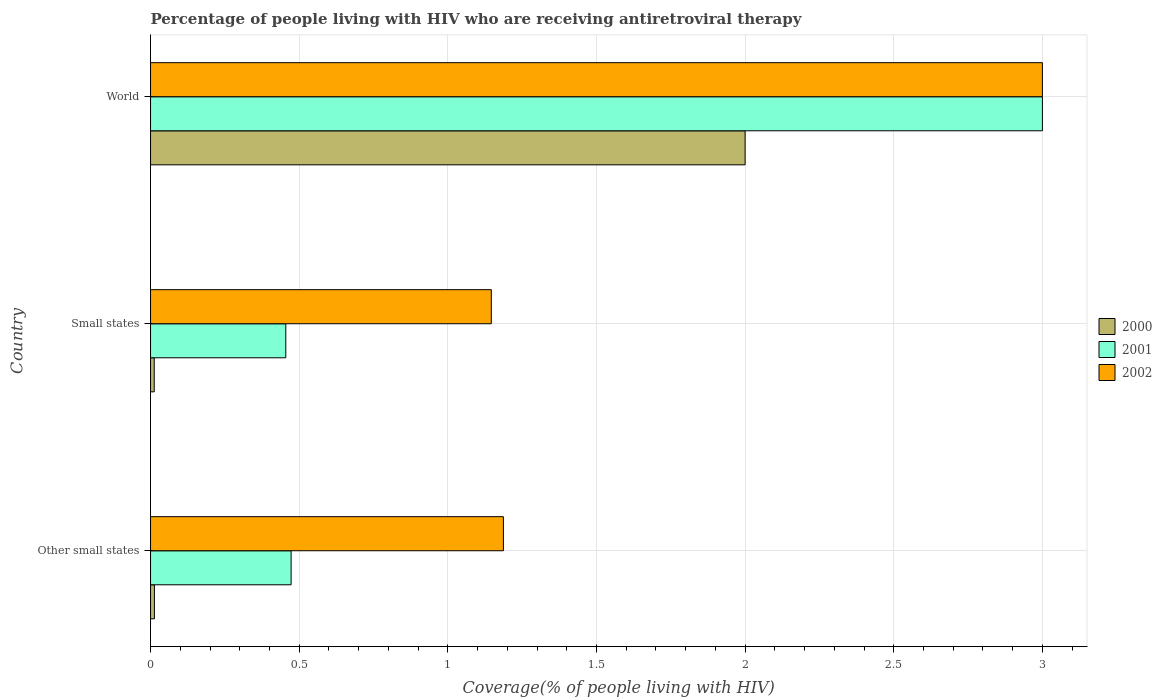Are the number of bars per tick equal to the number of legend labels?
Offer a terse response. Yes. Are the number of bars on each tick of the Y-axis equal?
Make the answer very short. Yes. How many bars are there on the 3rd tick from the bottom?
Keep it short and to the point. 3. What is the label of the 2nd group of bars from the top?
Keep it short and to the point. Small states. What is the percentage of the HIV infected people who are receiving antiretroviral therapy in 2002 in Small states?
Provide a short and direct response. 1.15. Across all countries, what is the minimum percentage of the HIV infected people who are receiving antiretroviral therapy in 2000?
Keep it short and to the point. 0.01. In which country was the percentage of the HIV infected people who are receiving antiretroviral therapy in 2001 maximum?
Your answer should be compact. World. In which country was the percentage of the HIV infected people who are receiving antiretroviral therapy in 2002 minimum?
Make the answer very short. Small states. What is the total percentage of the HIV infected people who are receiving antiretroviral therapy in 2002 in the graph?
Your answer should be very brief. 5.33. What is the difference between the percentage of the HIV infected people who are receiving antiretroviral therapy in 2000 in Other small states and that in World?
Provide a succinct answer. -1.99. What is the difference between the percentage of the HIV infected people who are receiving antiretroviral therapy in 2000 in Small states and the percentage of the HIV infected people who are receiving antiretroviral therapy in 2002 in World?
Ensure brevity in your answer.  -2.99. What is the average percentage of the HIV infected people who are receiving antiretroviral therapy in 2002 per country?
Offer a terse response. 1.78. What is the difference between the percentage of the HIV infected people who are receiving antiretroviral therapy in 2002 and percentage of the HIV infected people who are receiving antiretroviral therapy in 2001 in World?
Offer a terse response. 0. In how many countries, is the percentage of the HIV infected people who are receiving antiretroviral therapy in 2002 greater than 1.2 %?
Offer a terse response. 1. What is the ratio of the percentage of the HIV infected people who are receiving antiretroviral therapy in 2000 in Other small states to that in World?
Ensure brevity in your answer.  0.01. Is the percentage of the HIV infected people who are receiving antiretroviral therapy in 2001 in Other small states less than that in Small states?
Your response must be concise. No. What is the difference between the highest and the second highest percentage of the HIV infected people who are receiving antiretroviral therapy in 2000?
Your response must be concise. 1.99. What is the difference between the highest and the lowest percentage of the HIV infected people who are receiving antiretroviral therapy in 2000?
Make the answer very short. 1.99. Is the sum of the percentage of the HIV infected people who are receiving antiretroviral therapy in 2001 in Other small states and Small states greater than the maximum percentage of the HIV infected people who are receiving antiretroviral therapy in 2000 across all countries?
Keep it short and to the point. No. What does the 1st bar from the top in Other small states represents?
Provide a short and direct response. 2002. What does the 3rd bar from the bottom in Other small states represents?
Provide a succinct answer. 2002. Is it the case that in every country, the sum of the percentage of the HIV infected people who are receiving antiretroviral therapy in 2002 and percentage of the HIV infected people who are receiving antiretroviral therapy in 2000 is greater than the percentage of the HIV infected people who are receiving antiretroviral therapy in 2001?
Provide a short and direct response. Yes. How many countries are there in the graph?
Your answer should be compact. 3. Does the graph contain any zero values?
Keep it short and to the point. No. Where does the legend appear in the graph?
Provide a short and direct response. Center right. What is the title of the graph?
Ensure brevity in your answer.  Percentage of people living with HIV who are receiving antiretroviral therapy. Does "2000" appear as one of the legend labels in the graph?
Your answer should be very brief. Yes. What is the label or title of the X-axis?
Keep it short and to the point. Coverage(% of people living with HIV). What is the Coverage(% of people living with HIV) of 2000 in Other small states?
Make the answer very short. 0.01. What is the Coverage(% of people living with HIV) in 2001 in Other small states?
Provide a succinct answer. 0.47. What is the Coverage(% of people living with HIV) in 2002 in Other small states?
Keep it short and to the point. 1.19. What is the Coverage(% of people living with HIV) in 2000 in Small states?
Your response must be concise. 0.01. What is the Coverage(% of people living with HIV) of 2001 in Small states?
Ensure brevity in your answer.  0.45. What is the Coverage(% of people living with HIV) of 2002 in Small states?
Your response must be concise. 1.15. What is the Coverage(% of people living with HIV) of 2000 in World?
Keep it short and to the point. 2. What is the Coverage(% of people living with HIV) in 2001 in World?
Provide a succinct answer. 3. Across all countries, what is the maximum Coverage(% of people living with HIV) of 2001?
Provide a succinct answer. 3. Across all countries, what is the maximum Coverage(% of people living with HIV) of 2002?
Provide a short and direct response. 3. Across all countries, what is the minimum Coverage(% of people living with HIV) in 2000?
Keep it short and to the point. 0.01. Across all countries, what is the minimum Coverage(% of people living with HIV) of 2001?
Make the answer very short. 0.45. Across all countries, what is the minimum Coverage(% of people living with HIV) of 2002?
Your answer should be compact. 1.15. What is the total Coverage(% of people living with HIV) of 2000 in the graph?
Give a very brief answer. 2.03. What is the total Coverage(% of people living with HIV) in 2001 in the graph?
Offer a terse response. 3.93. What is the total Coverage(% of people living with HIV) in 2002 in the graph?
Offer a very short reply. 5.33. What is the difference between the Coverage(% of people living with HIV) of 2000 in Other small states and that in Small states?
Ensure brevity in your answer.  0. What is the difference between the Coverage(% of people living with HIV) in 2001 in Other small states and that in Small states?
Your response must be concise. 0.02. What is the difference between the Coverage(% of people living with HIV) of 2002 in Other small states and that in Small states?
Give a very brief answer. 0.04. What is the difference between the Coverage(% of people living with HIV) in 2000 in Other small states and that in World?
Your answer should be very brief. -1.99. What is the difference between the Coverage(% of people living with HIV) of 2001 in Other small states and that in World?
Provide a short and direct response. -2.53. What is the difference between the Coverage(% of people living with HIV) in 2002 in Other small states and that in World?
Provide a succinct answer. -1.81. What is the difference between the Coverage(% of people living with HIV) in 2000 in Small states and that in World?
Keep it short and to the point. -1.99. What is the difference between the Coverage(% of people living with HIV) in 2001 in Small states and that in World?
Ensure brevity in your answer.  -2.54. What is the difference between the Coverage(% of people living with HIV) of 2002 in Small states and that in World?
Provide a short and direct response. -1.85. What is the difference between the Coverage(% of people living with HIV) in 2000 in Other small states and the Coverage(% of people living with HIV) in 2001 in Small states?
Your response must be concise. -0.44. What is the difference between the Coverage(% of people living with HIV) of 2000 in Other small states and the Coverage(% of people living with HIV) of 2002 in Small states?
Your answer should be compact. -1.13. What is the difference between the Coverage(% of people living with HIV) of 2001 in Other small states and the Coverage(% of people living with HIV) of 2002 in Small states?
Offer a very short reply. -0.67. What is the difference between the Coverage(% of people living with HIV) of 2000 in Other small states and the Coverage(% of people living with HIV) of 2001 in World?
Ensure brevity in your answer.  -2.99. What is the difference between the Coverage(% of people living with HIV) in 2000 in Other small states and the Coverage(% of people living with HIV) in 2002 in World?
Your answer should be very brief. -2.99. What is the difference between the Coverage(% of people living with HIV) of 2001 in Other small states and the Coverage(% of people living with HIV) of 2002 in World?
Offer a terse response. -2.53. What is the difference between the Coverage(% of people living with HIV) in 2000 in Small states and the Coverage(% of people living with HIV) in 2001 in World?
Make the answer very short. -2.99. What is the difference between the Coverage(% of people living with HIV) in 2000 in Small states and the Coverage(% of people living with HIV) in 2002 in World?
Your answer should be compact. -2.99. What is the difference between the Coverage(% of people living with HIV) of 2001 in Small states and the Coverage(% of people living with HIV) of 2002 in World?
Your answer should be very brief. -2.54. What is the average Coverage(% of people living with HIV) in 2000 per country?
Your response must be concise. 0.68. What is the average Coverage(% of people living with HIV) of 2001 per country?
Make the answer very short. 1.31. What is the average Coverage(% of people living with HIV) of 2002 per country?
Your response must be concise. 1.78. What is the difference between the Coverage(% of people living with HIV) in 2000 and Coverage(% of people living with HIV) in 2001 in Other small states?
Ensure brevity in your answer.  -0.46. What is the difference between the Coverage(% of people living with HIV) in 2000 and Coverage(% of people living with HIV) in 2002 in Other small states?
Your answer should be compact. -1.17. What is the difference between the Coverage(% of people living with HIV) of 2001 and Coverage(% of people living with HIV) of 2002 in Other small states?
Offer a terse response. -0.71. What is the difference between the Coverage(% of people living with HIV) in 2000 and Coverage(% of people living with HIV) in 2001 in Small states?
Provide a succinct answer. -0.44. What is the difference between the Coverage(% of people living with HIV) in 2000 and Coverage(% of people living with HIV) in 2002 in Small states?
Keep it short and to the point. -1.13. What is the difference between the Coverage(% of people living with HIV) in 2001 and Coverage(% of people living with HIV) in 2002 in Small states?
Your response must be concise. -0.69. What is the ratio of the Coverage(% of people living with HIV) of 2000 in Other small states to that in Small states?
Your answer should be very brief. 1.05. What is the ratio of the Coverage(% of people living with HIV) in 2001 in Other small states to that in Small states?
Your answer should be very brief. 1.04. What is the ratio of the Coverage(% of people living with HIV) in 2002 in Other small states to that in Small states?
Your answer should be compact. 1.04. What is the ratio of the Coverage(% of people living with HIV) of 2000 in Other small states to that in World?
Offer a very short reply. 0.01. What is the ratio of the Coverage(% of people living with HIV) of 2001 in Other small states to that in World?
Give a very brief answer. 0.16. What is the ratio of the Coverage(% of people living with HIV) in 2002 in Other small states to that in World?
Your response must be concise. 0.4. What is the ratio of the Coverage(% of people living with HIV) in 2000 in Small states to that in World?
Provide a short and direct response. 0.01. What is the ratio of the Coverage(% of people living with HIV) of 2001 in Small states to that in World?
Give a very brief answer. 0.15. What is the ratio of the Coverage(% of people living with HIV) in 2002 in Small states to that in World?
Your answer should be compact. 0.38. What is the difference between the highest and the second highest Coverage(% of people living with HIV) of 2000?
Offer a terse response. 1.99. What is the difference between the highest and the second highest Coverage(% of people living with HIV) of 2001?
Make the answer very short. 2.53. What is the difference between the highest and the second highest Coverage(% of people living with HIV) of 2002?
Ensure brevity in your answer.  1.81. What is the difference between the highest and the lowest Coverage(% of people living with HIV) in 2000?
Your answer should be compact. 1.99. What is the difference between the highest and the lowest Coverage(% of people living with HIV) in 2001?
Ensure brevity in your answer.  2.54. What is the difference between the highest and the lowest Coverage(% of people living with HIV) of 2002?
Offer a very short reply. 1.85. 